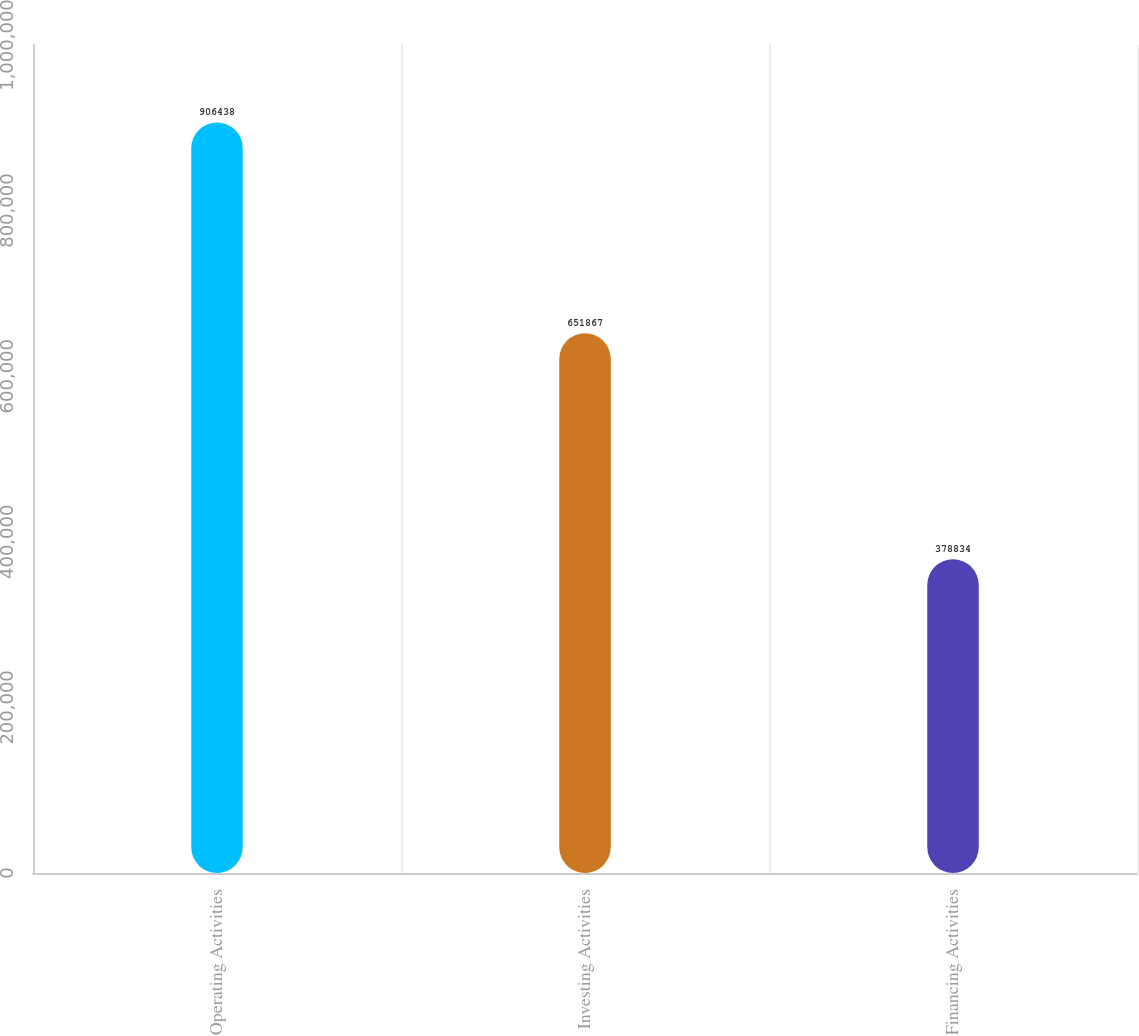Convert chart to OTSL. <chart><loc_0><loc_0><loc_500><loc_500><bar_chart><fcel>Operating Activities<fcel>Investing Activities<fcel>Financing Activities<nl><fcel>906438<fcel>651867<fcel>378834<nl></chart> 